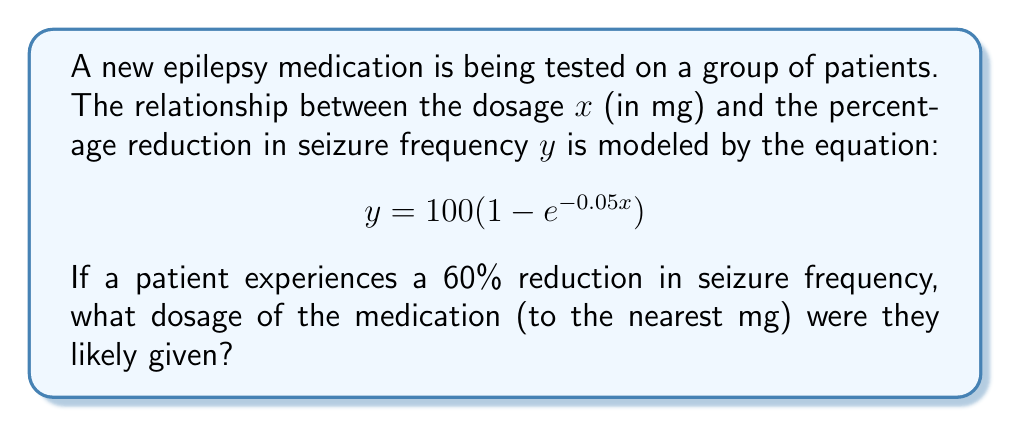What is the answer to this math problem? To solve this inverse problem, we need to work backwards from the observed symptom reduction to determine the medication dosage. Let's approach this step-by-step:

1) We're given that $y = 60$ (60% reduction in seizure frequency).

2) Substitute this into the equation:
   $$60 = 100(1 - e^{-0.05x})$$

3) Divide both sides by 100:
   $$0.6 = 1 - e^{-0.05x}$$

4) Subtract both sides from 1:
   $$0.4 = e^{-0.05x}$$

5) Take the natural logarithm of both sides:
   $$\ln(0.4) = -0.05x$$

6) Divide both sides by -0.05:
   $$\frac{\ln(0.4)}{-0.05} = x$$

7) Calculate:
   $$x = \frac{\ln(0.4)}{-0.05} \approx 18.3$$

8) Rounding to the nearest mg:
   $$x \approx 18 \text{ mg}$$

Therefore, the patient was likely given a dosage of 18 mg of the medication.
Answer: 18 mg 